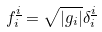<formula> <loc_0><loc_0><loc_500><loc_500>f _ { i } ^ { \underline { i } } = \sqrt { \left | g _ { i } \right | } \delta _ { i } ^ { \underline { i } }</formula> 